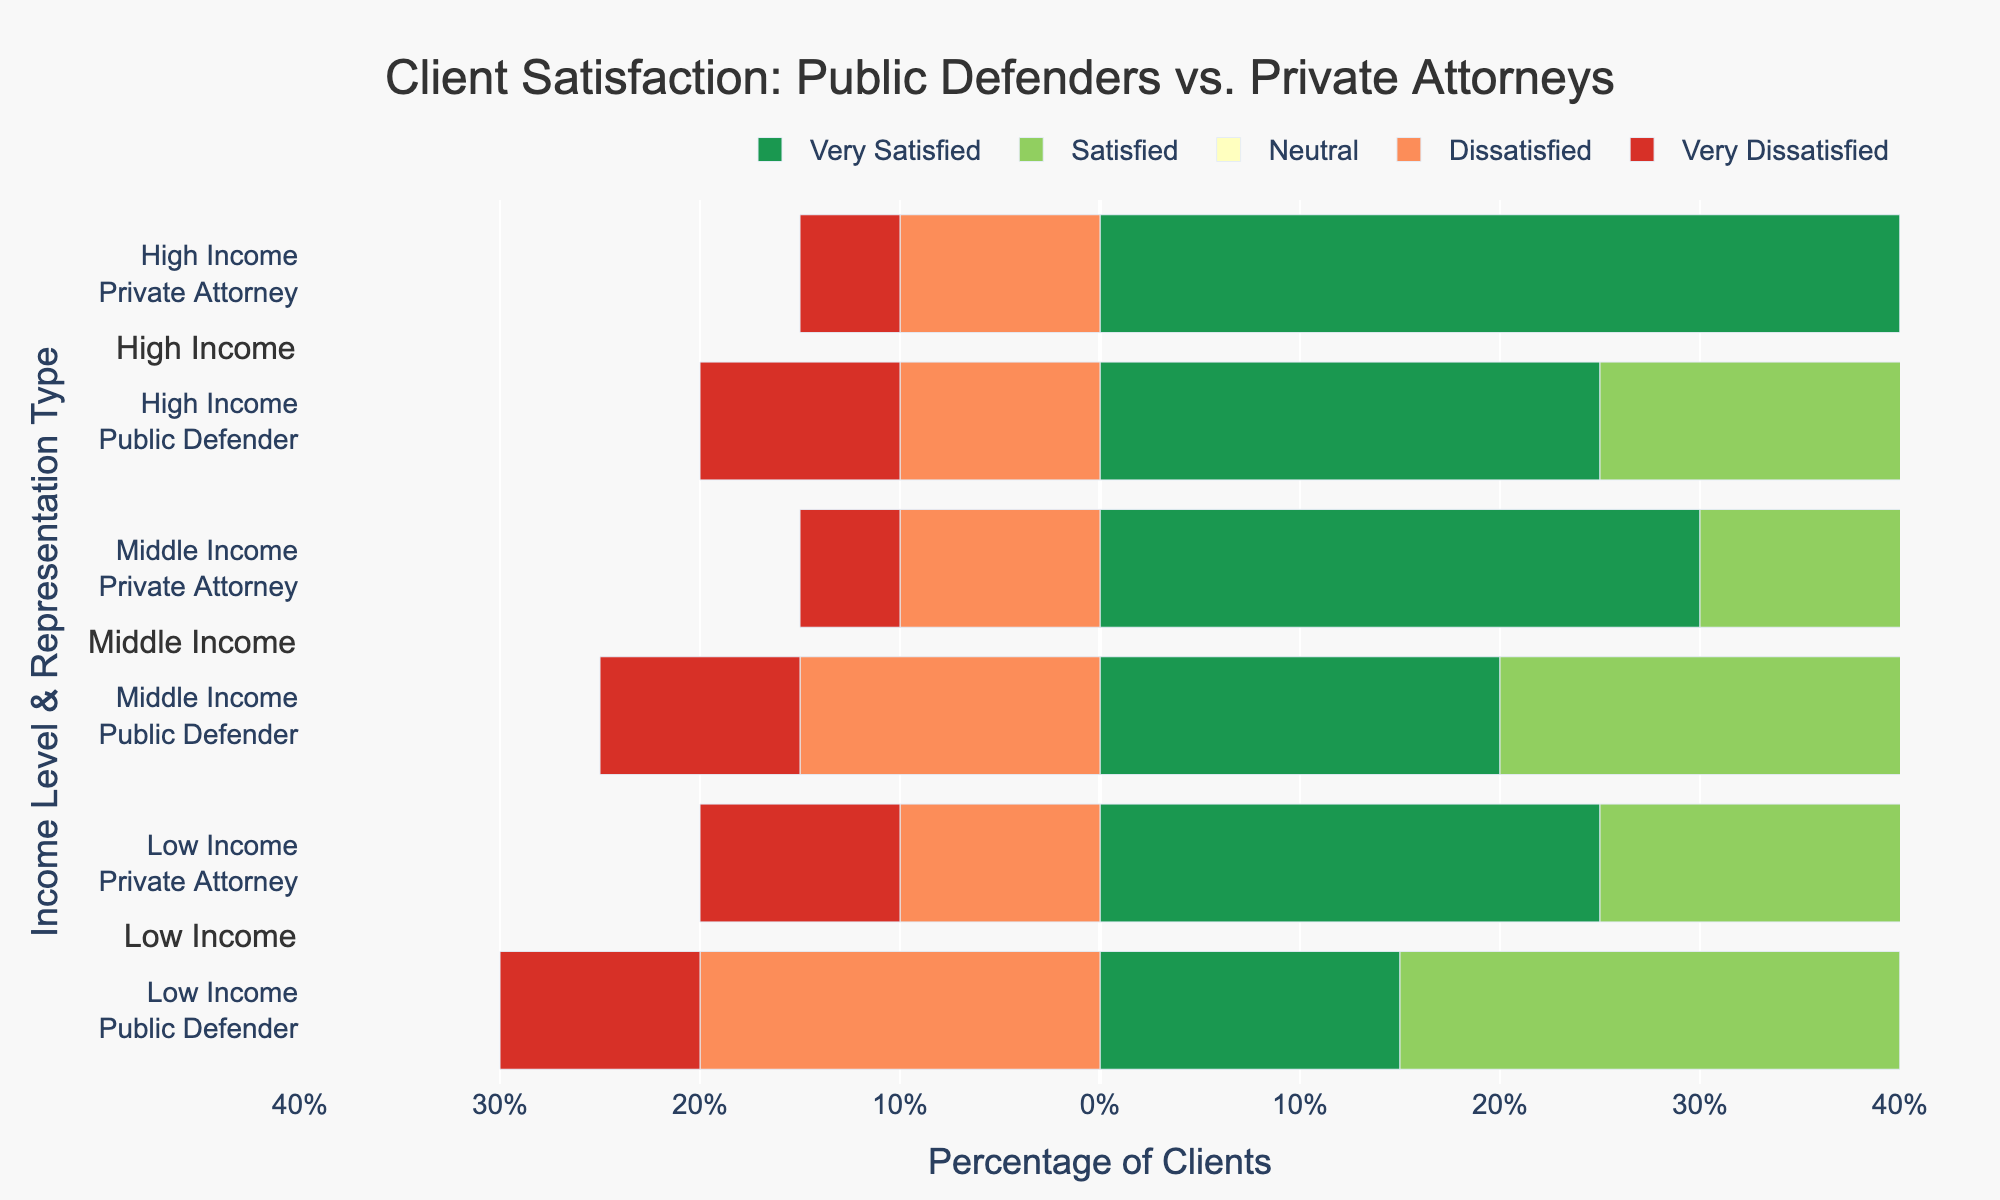What percentage of clients in the High Income level are very satisfied with Private Attorneys? Look at the High-Income row for Private Attorneys. The "Very Satisfied" bar has a length corresponding to 40%.
Answer: 40% By how much does client satisfaction (very satisfied and satisfied combined) differ between Public Defenders and Private Attorneys for Low-Income clients? For Low-Income clients with Public Defenders, combine the percentages for "Very Satisfied" and "Satisfied" (15% + 25% = 40%). For Private Attorneys, this is (25% + 30% = 55%). The difference is 55% - 40% = 15%.
Answer: 15% Which representation type has the highest satisfied percentage for Middle-Income clients? Look at the "Satisfied" bars for Middle-Income clients. The "Satisfied" bar for Private Attorneys is 35%, while for Public Defenders, it is 30%. Private Attorneys have the higher percentage.
Answer: Private Attorneys What is the combined percentage of dissatisfaction (dissatisfied and very dissatisfied combined) for High-Income clients with Public Defenders? Look at the "Dissatisfied" and "Very Dissatisfied" bars for High-Income clients with Public Defenders. The percentages are 10% for both categories, so the combined percentage is 10% + 10% = 20%.
Answer: 20% Compare the neutral satisfaction levels between Middle-Income clients with Public Defenders and Private Attorneys. Which one is higher? Look at the "Neutral" bar for Middle-Income clients. For Public Defenders, it is 25%; for Private Attorneys, it is 20%. Public Defenders have the higher neutral satisfaction level.
Answer: Public Defenders How does the overall dissatisfaction (dissatisfied and very dissatisfied combined) for Low-Income clients with Private Attorneys compare to that for High-Income clients with Public Defenders? For Low-Income clients with Private Attorneys, the dissatisfaction percentage is (10% for Dissatisfied + 10% for Very Dissatisfied) = 20%. For High-Income clients with Public Defenders, the dissatisfaction percentage is (10% + 10% = 20%). Both are equal.
Answer: Equal What is the total percentage of clients, across all income levels, who are either very dissatisfied or dissatisfied with Public Defenders? Sum the percentages for "Very Dissatisfied" and "Dissatisfied" across all income levels with Public Defenders. Low Income: 20%+10% = 30%. Middle Income: 15%+10% = 25%. High Income: 10%+10% = 20%. Total = 30% + 25% + 20% = 75%.
Answer: 75% Compare the percentage of very satisfied clients between Public Defenders and Private Attorneys within each income level. For Low Income: 15% (Public) vs. 25% (Private). For Middle Income: 20% (Public) vs. 30% (Private). For High Income: 25% (Public) vs. 40% (Private). Private Attorneys have a higher percentage in all income levels.
Answer: Private Attorneys What is the least common satisfaction level among Middle-Income clients with Private Attorneys? For Middle-Income clients with Private Attorneys, the percentages are 30% (Very Satisfied), 35% (Satisfied), 20% (Neutral), 10% (Dissatisfied), and 5% (Very Dissatisfied). The least common satisfaction level is Very Dissatisfied at 5%.
Answer: Very Dissatisfied 